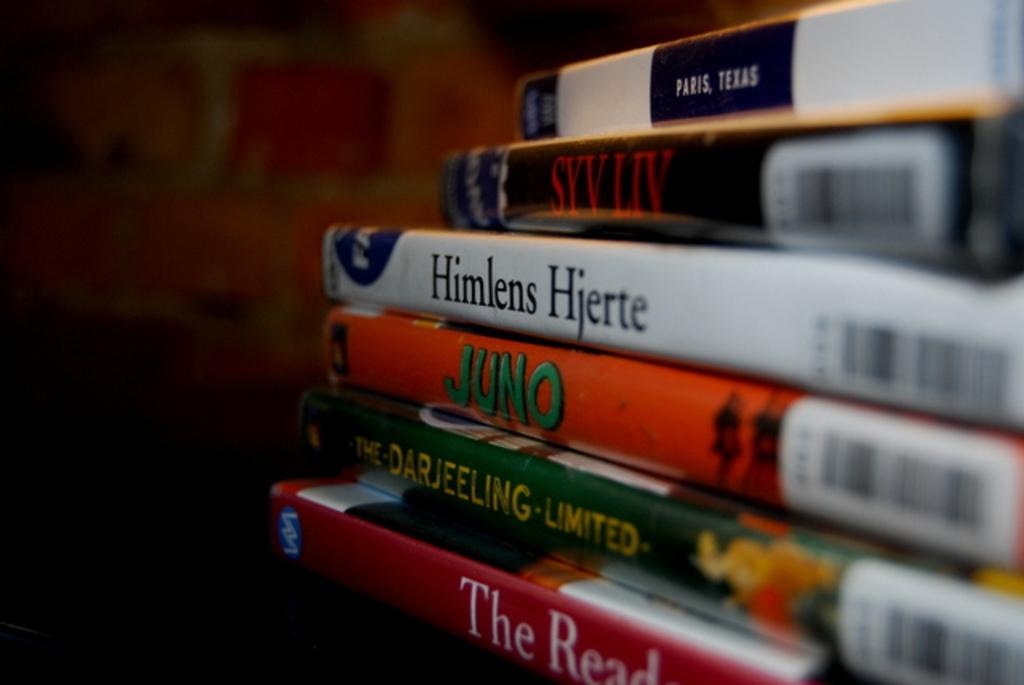What is the title of the middle orange book?
Offer a terse response. Juno. 